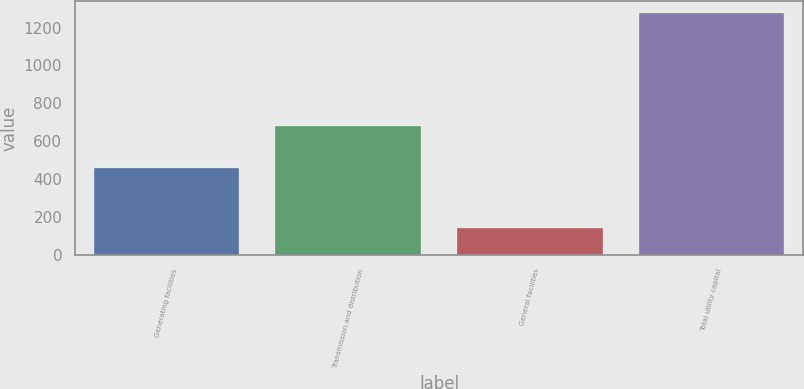Convert chart. <chart><loc_0><loc_0><loc_500><loc_500><bar_chart><fcel>Generating facilities<fcel>Transmission and distribution<fcel>General facilities<fcel>Total utility capital<nl><fcel>458<fcel>678<fcel>142<fcel>1278<nl></chart> 